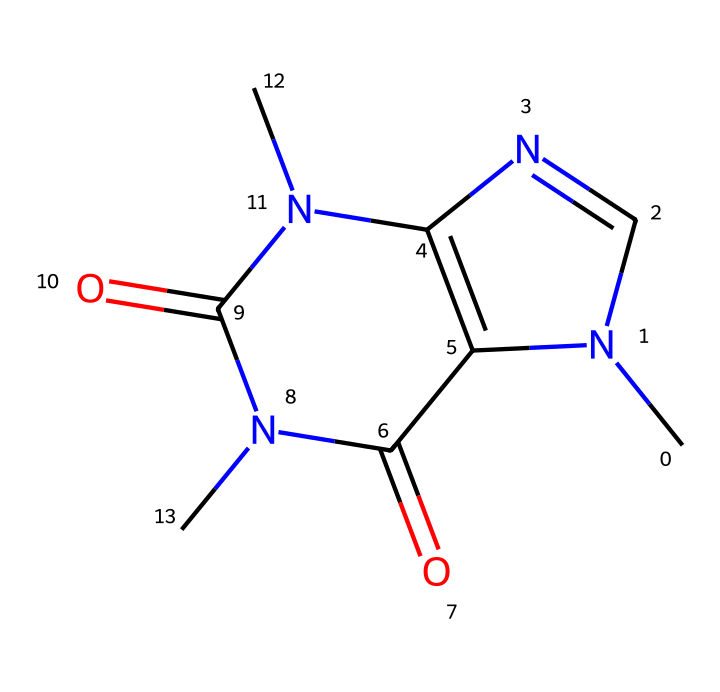What is the molecular formula of caffeine? By analyzing the chemical structure, we can identify the components making up caffeine. The structure comprises 8 carbon atoms, 10 hydrogen atoms, 4 nitrogen atoms, and 2 oxygen atoms, leading to the molecular formula C8H10N4O2.
Answer: C8H10N4O2 How many nitrogen atoms are present in caffeine? An inspection of the structure shows there are four distinct nitrogen atoms present within the molecule.
Answer: 4 What type of functional groups are found in caffeine? The chemical structure indicates the presence of amine and carbonyl functional groups. The nitrogen atoms contribute to the amine functionality, while the carbonyls are visible on the carbon atoms connected to oxygen atoms.
Answer: amine, carbonyl Which part of the caffeine molecule is responsible for its stimulant properties? The nitrogen atoms in the structure allow caffeine to interact with adenosine receptors in the brain. The presence of multiple nitrogen atoms, specifically in a cyclic arrangement, is critical for its stimulating effects.
Answer: nitrogen atoms Is caffeine classified as an alkaloid? Caffeine is a nitrogen-containing compound that fits the definition of an alkaloid due to its natural occurrence in plants and its pharmacological effects. Its structure, with multiple nitrogen atoms, reinforces this classification.
Answer: yes 